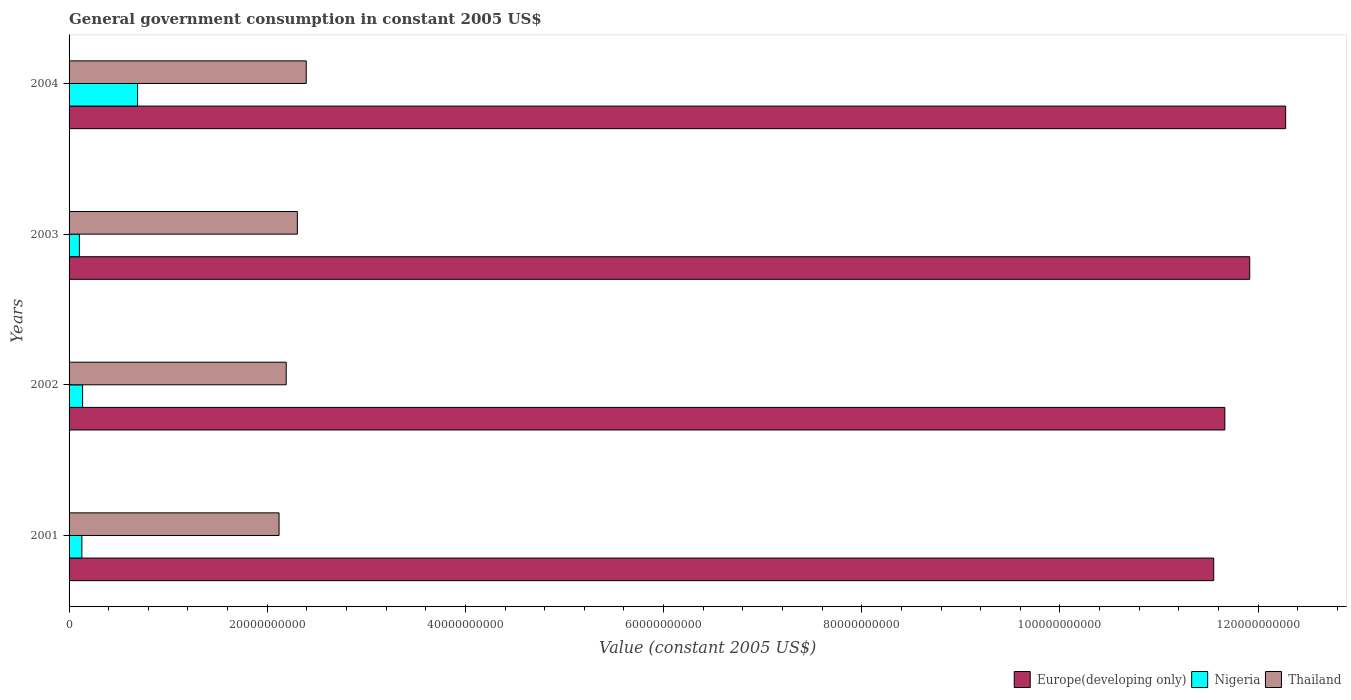How many different coloured bars are there?
Make the answer very short. 3. What is the label of the 4th group of bars from the top?
Provide a short and direct response. 2001. In how many cases, is the number of bars for a given year not equal to the number of legend labels?
Provide a succinct answer. 0. What is the government conusmption in Europe(developing only) in 2004?
Your answer should be very brief. 1.23e+11. Across all years, what is the maximum government conusmption in Europe(developing only)?
Provide a short and direct response. 1.23e+11. Across all years, what is the minimum government conusmption in Thailand?
Make the answer very short. 2.12e+1. In which year was the government conusmption in Thailand maximum?
Your answer should be compact. 2004. In which year was the government conusmption in Nigeria minimum?
Your response must be concise. 2003. What is the total government conusmption in Europe(developing only) in the graph?
Offer a very short reply. 4.74e+11. What is the difference between the government conusmption in Europe(developing only) in 2001 and that in 2002?
Your answer should be compact. -1.12e+09. What is the difference between the government conusmption in Europe(developing only) in 2004 and the government conusmption in Nigeria in 2001?
Keep it short and to the point. 1.21e+11. What is the average government conusmption in Nigeria per year?
Offer a terse response. 2.65e+09. In the year 2003, what is the difference between the government conusmption in Nigeria and government conusmption in Europe(developing only)?
Provide a short and direct response. -1.18e+11. What is the ratio of the government conusmption in Nigeria in 2001 to that in 2003?
Provide a succinct answer. 1.24. What is the difference between the highest and the second highest government conusmption in Nigeria?
Offer a very short reply. 5.55e+09. What is the difference between the highest and the lowest government conusmption in Thailand?
Keep it short and to the point. 2.74e+09. Is the sum of the government conusmption in Thailand in 2002 and 2003 greater than the maximum government conusmption in Nigeria across all years?
Provide a short and direct response. Yes. What does the 1st bar from the top in 2002 represents?
Provide a succinct answer. Thailand. What does the 1st bar from the bottom in 2002 represents?
Your response must be concise. Europe(developing only). Are all the bars in the graph horizontal?
Your answer should be very brief. Yes. Does the graph contain any zero values?
Provide a short and direct response. No. Where does the legend appear in the graph?
Make the answer very short. Bottom right. How many legend labels are there?
Give a very brief answer. 3. What is the title of the graph?
Keep it short and to the point. General government consumption in constant 2005 US$. Does "Georgia" appear as one of the legend labels in the graph?
Provide a succinct answer. No. What is the label or title of the X-axis?
Offer a terse response. Value (constant 2005 US$). What is the label or title of the Y-axis?
Offer a very short reply. Years. What is the Value (constant 2005 US$) of Europe(developing only) in 2001?
Give a very brief answer. 1.16e+11. What is the Value (constant 2005 US$) of Nigeria in 2001?
Offer a terse response. 1.29e+09. What is the Value (constant 2005 US$) of Thailand in 2001?
Make the answer very short. 2.12e+1. What is the Value (constant 2005 US$) of Europe(developing only) in 2002?
Make the answer very short. 1.17e+11. What is the Value (constant 2005 US$) of Nigeria in 2002?
Your answer should be compact. 1.37e+09. What is the Value (constant 2005 US$) of Thailand in 2002?
Offer a very short reply. 2.19e+1. What is the Value (constant 2005 US$) in Europe(developing only) in 2003?
Your answer should be compact. 1.19e+11. What is the Value (constant 2005 US$) of Nigeria in 2003?
Provide a short and direct response. 1.04e+09. What is the Value (constant 2005 US$) in Thailand in 2003?
Offer a terse response. 2.30e+1. What is the Value (constant 2005 US$) of Europe(developing only) in 2004?
Offer a terse response. 1.23e+11. What is the Value (constant 2005 US$) in Nigeria in 2004?
Offer a very short reply. 6.92e+09. What is the Value (constant 2005 US$) in Thailand in 2004?
Ensure brevity in your answer.  2.39e+1. Across all years, what is the maximum Value (constant 2005 US$) in Europe(developing only)?
Give a very brief answer. 1.23e+11. Across all years, what is the maximum Value (constant 2005 US$) in Nigeria?
Offer a very short reply. 6.92e+09. Across all years, what is the maximum Value (constant 2005 US$) in Thailand?
Your answer should be compact. 2.39e+1. Across all years, what is the minimum Value (constant 2005 US$) of Europe(developing only)?
Provide a short and direct response. 1.16e+11. Across all years, what is the minimum Value (constant 2005 US$) in Nigeria?
Offer a very short reply. 1.04e+09. Across all years, what is the minimum Value (constant 2005 US$) in Thailand?
Your response must be concise. 2.12e+1. What is the total Value (constant 2005 US$) of Europe(developing only) in the graph?
Give a very brief answer. 4.74e+11. What is the total Value (constant 2005 US$) of Nigeria in the graph?
Your answer should be compact. 1.06e+1. What is the total Value (constant 2005 US$) in Thailand in the graph?
Give a very brief answer. 9.01e+1. What is the difference between the Value (constant 2005 US$) of Europe(developing only) in 2001 and that in 2002?
Your answer should be very brief. -1.12e+09. What is the difference between the Value (constant 2005 US$) in Nigeria in 2001 and that in 2002?
Your answer should be compact. -7.46e+07. What is the difference between the Value (constant 2005 US$) of Thailand in 2001 and that in 2002?
Offer a terse response. -7.23e+08. What is the difference between the Value (constant 2005 US$) in Europe(developing only) in 2001 and that in 2003?
Your answer should be very brief. -3.63e+09. What is the difference between the Value (constant 2005 US$) in Nigeria in 2001 and that in 2003?
Provide a short and direct response. 2.52e+08. What is the difference between the Value (constant 2005 US$) of Thailand in 2001 and that in 2003?
Ensure brevity in your answer.  -1.85e+09. What is the difference between the Value (constant 2005 US$) in Europe(developing only) in 2001 and that in 2004?
Ensure brevity in your answer.  -7.26e+09. What is the difference between the Value (constant 2005 US$) in Nigeria in 2001 and that in 2004?
Make the answer very short. -5.63e+09. What is the difference between the Value (constant 2005 US$) of Thailand in 2001 and that in 2004?
Make the answer very short. -2.74e+09. What is the difference between the Value (constant 2005 US$) in Europe(developing only) in 2002 and that in 2003?
Make the answer very short. -2.51e+09. What is the difference between the Value (constant 2005 US$) of Nigeria in 2002 and that in 2003?
Make the answer very short. 3.27e+08. What is the difference between the Value (constant 2005 US$) of Thailand in 2002 and that in 2003?
Make the answer very short. -1.12e+09. What is the difference between the Value (constant 2005 US$) in Europe(developing only) in 2002 and that in 2004?
Provide a succinct answer. -6.14e+09. What is the difference between the Value (constant 2005 US$) in Nigeria in 2002 and that in 2004?
Your response must be concise. -5.55e+09. What is the difference between the Value (constant 2005 US$) in Thailand in 2002 and that in 2004?
Give a very brief answer. -2.02e+09. What is the difference between the Value (constant 2005 US$) of Europe(developing only) in 2003 and that in 2004?
Keep it short and to the point. -3.63e+09. What is the difference between the Value (constant 2005 US$) of Nigeria in 2003 and that in 2004?
Keep it short and to the point. -5.88e+09. What is the difference between the Value (constant 2005 US$) of Thailand in 2003 and that in 2004?
Your answer should be compact. -8.98e+08. What is the difference between the Value (constant 2005 US$) in Europe(developing only) in 2001 and the Value (constant 2005 US$) in Nigeria in 2002?
Your answer should be very brief. 1.14e+11. What is the difference between the Value (constant 2005 US$) of Europe(developing only) in 2001 and the Value (constant 2005 US$) of Thailand in 2002?
Your answer should be very brief. 9.36e+1. What is the difference between the Value (constant 2005 US$) in Nigeria in 2001 and the Value (constant 2005 US$) in Thailand in 2002?
Your answer should be very brief. -2.06e+1. What is the difference between the Value (constant 2005 US$) of Europe(developing only) in 2001 and the Value (constant 2005 US$) of Nigeria in 2003?
Offer a very short reply. 1.14e+11. What is the difference between the Value (constant 2005 US$) in Europe(developing only) in 2001 and the Value (constant 2005 US$) in Thailand in 2003?
Ensure brevity in your answer.  9.25e+1. What is the difference between the Value (constant 2005 US$) in Nigeria in 2001 and the Value (constant 2005 US$) in Thailand in 2003?
Your answer should be compact. -2.17e+1. What is the difference between the Value (constant 2005 US$) of Europe(developing only) in 2001 and the Value (constant 2005 US$) of Nigeria in 2004?
Your answer should be compact. 1.09e+11. What is the difference between the Value (constant 2005 US$) in Europe(developing only) in 2001 and the Value (constant 2005 US$) in Thailand in 2004?
Your response must be concise. 9.16e+1. What is the difference between the Value (constant 2005 US$) in Nigeria in 2001 and the Value (constant 2005 US$) in Thailand in 2004?
Give a very brief answer. -2.26e+1. What is the difference between the Value (constant 2005 US$) in Europe(developing only) in 2002 and the Value (constant 2005 US$) in Nigeria in 2003?
Keep it short and to the point. 1.16e+11. What is the difference between the Value (constant 2005 US$) of Europe(developing only) in 2002 and the Value (constant 2005 US$) of Thailand in 2003?
Provide a succinct answer. 9.36e+1. What is the difference between the Value (constant 2005 US$) of Nigeria in 2002 and the Value (constant 2005 US$) of Thailand in 2003?
Give a very brief answer. -2.17e+1. What is the difference between the Value (constant 2005 US$) in Europe(developing only) in 2002 and the Value (constant 2005 US$) in Nigeria in 2004?
Offer a very short reply. 1.10e+11. What is the difference between the Value (constant 2005 US$) in Europe(developing only) in 2002 and the Value (constant 2005 US$) in Thailand in 2004?
Your answer should be very brief. 9.27e+1. What is the difference between the Value (constant 2005 US$) in Nigeria in 2002 and the Value (constant 2005 US$) in Thailand in 2004?
Your response must be concise. -2.26e+1. What is the difference between the Value (constant 2005 US$) in Europe(developing only) in 2003 and the Value (constant 2005 US$) in Nigeria in 2004?
Offer a very short reply. 1.12e+11. What is the difference between the Value (constant 2005 US$) of Europe(developing only) in 2003 and the Value (constant 2005 US$) of Thailand in 2004?
Your response must be concise. 9.52e+1. What is the difference between the Value (constant 2005 US$) of Nigeria in 2003 and the Value (constant 2005 US$) of Thailand in 2004?
Keep it short and to the point. -2.29e+1. What is the average Value (constant 2005 US$) in Europe(developing only) per year?
Make the answer very short. 1.19e+11. What is the average Value (constant 2005 US$) in Nigeria per year?
Your response must be concise. 2.65e+09. What is the average Value (constant 2005 US$) of Thailand per year?
Ensure brevity in your answer.  2.25e+1. In the year 2001, what is the difference between the Value (constant 2005 US$) of Europe(developing only) and Value (constant 2005 US$) of Nigeria?
Your response must be concise. 1.14e+11. In the year 2001, what is the difference between the Value (constant 2005 US$) in Europe(developing only) and Value (constant 2005 US$) in Thailand?
Offer a very short reply. 9.43e+1. In the year 2001, what is the difference between the Value (constant 2005 US$) of Nigeria and Value (constant 2005 US$) of Thailand?
Keep it short and to the point. -1.99e+1. In the year 2002, what is the difference between the Value (constant 2005 US$) in Europe(developing only) and Value (constant 2005 US$) in Nigeria?
Make the answer very short. 1.15e+11. In the year 2002, what is the difference between the Value (constant 2005 US$) of Europe(developing only) and Value (constant 2005 US$) of Thailand?
Your answer should be compact. 9.47e+1. In the year 2002, what is the difference between the Value (constant 2005 US$) in Nigeria and Value (constant 2005 US$) in Thailand?
Your response must be concise. -2.05e+1. In the year 2003, what is the difference between the Value (constant 2005 US$) in Europe(developing only) and Value (constant 2005 US$) in Nigeria?
Your response must be concise. 1.18e+11. In the year 2003, what is the difference between the Value (constant 2005 US$) of Europe(developing only) and Value (constant 2005 US$) of Thailand?
Your answer should be compact. 9.61e+1. In the year 2003, what is the difference between the Value (constant 2005 US$) of Nigeria and Value (constant 2005 US$) of Thailand?
Provide a succinct answer. -2.20e+1. In the year 2004, what is the difference between the Value (constant 2005 US$) in Europe(developing only) and Value (constant 2005 US$) in Nigeria?
Make the answer very short. 1.16e+11. In the year 2004, what is the difference between the Value (constant 2005 US$) of Europe(developing only) and Value (constant 2005 US$) of Thailand?
Your answer should be compact. 9.88e+1. In the year 2004, what is the difference between the Value (constant 2005 US$) in Nigeria and Value (constant 2005 US$) in Thailand?
Your answer should be compact. -1.70e+1. What is the ratio of the Value (constant 2005 US$) of Nigeria in 2001 to that in 2002?
Offer a very short reply. 0.95. What is the ratio of the Value (constant 2005 US$) of Europe(developing only) in 2001 to that in 2003?
Your response must be concise. 0.97. What is the ratio of the Value (constant 2005 US$) of Nigeria in 2001 to that in 2003?
Your answer should be compact. 1.24. What is the ratio of the Value (constant 2005 US$) of Thailand in 2001 to that in 2003?
Your answer should be compact. 0.92. What is the ratio of the Value (constant 2005 US$) in Europe(developing only) in 2001 to that in 2004?
Your response must be concise. 0.94. What is the ratio of the Value (constant 2005 US$) of Nigeria in 2001 to that in 2004?
Ensure brevity in your answer.  0.19. What is the ratio of the Value (constant 2005 US$) in Thailand in 2001 to that in 2004?
Provide a short and direct response. 0.89. What is the ratio of the Value (constant 2005 US$) of Nigeria in 2002 to that in 2003?
Offer a very short reply. 1.31. What is the ratio of the Value (constant 2005 US$) in Thailand in 2002 to that in 2003?
Make the answer very short. 0.95. What is the ratio of the Value (constant 2005 US$) in Nigeria in 2002 to that in 2004?
Your response must be concise. 0.2. What is the ratio of the Value (constant 2005 US$) of Thailand in 2002 to that in 2004?
Ensure brevity in your answer.  0.92. What is the ratio of the Value (constant 2005 US$) in Europe(developing only) in 2003 to that in 2004?
Offer a very short reply. 0.97. What is the ratio of the Value (constant 2005 US$) of Nigeria in 2003 to that in 2004?
Make the answer very short. 0.15. What is the ratio of the Value (constant 2005 US$) in Thailand in 2003 to that in 2004?
Ensure brevity in your answer.  0.96. What is the difference between the highest and the second highest Value (constant 2005 US$) of Europe(developing only)?
Make the answer very short. 3.63e+09. What is the difference between the highest and the second highest Value (constant 2005 US$) of Nigeria?
Your answer should be very brief. 5.55e+09. What is the difference between the highest and the second highest Value (constant 2005 US$) of Thailand?
Provide a succinct answer. 8.98e+08. What is the difference between the highest and the lowest Value (constant 2005 US$) in Europe(developing only)?
Ensure brevity in your answer.  7.26e+09. What is the difference between the highest and the lowest Value (constant 2005 US$) of Nigeria?
Offer a very short reply. 5.88e+09. What is the difference between the highest and the lowest Value (constant 2005 US$) of Thailand?
Your answer should be very brief. 2.74e+09. 